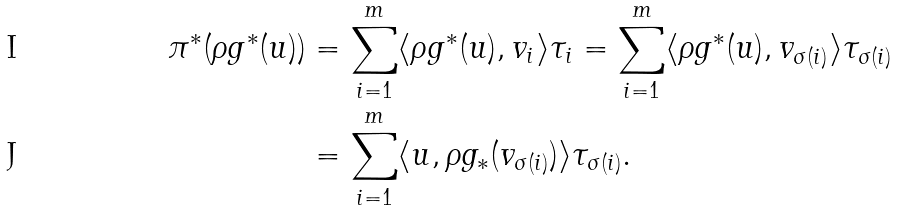Convert formula to latex. <formula><loc_0><loc_0><loc_500><loc_500>\pi ^ { * } ( \rho g ^ { * } ( u ) ) & = \sum _ { i = 1 } ^ { m } \langle \rho g ^ { * } ( u ) , v _ { i } \rangle \tau _ { i } = \sum _ { i = 1 } ^ { m } \langle \rho g ^ { * } ( u ) , v _ { \sigma ( i ) } \rangle \tau _ { \sigma ( i ) } \\ & = \sum _ { i = 1 } ^ { m } \langle u , \rho g _ { * } ( v _ { \sigma ( i ) } ) \rangle \tau _ { \sigma ( i ) } .</formula> 